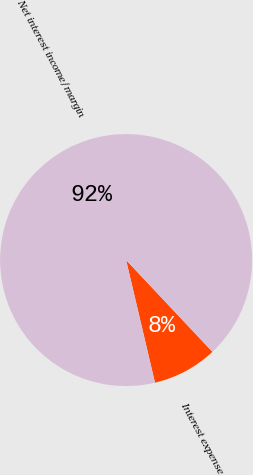Convert chart to OTSL. <chart><loc_0><loc_0><loc_500><loc_500><pie_chart><fcel>Interest expense<fcel>Net interest income/margin<nl><fcel>8.33%<fcel>91.67%<nl></chart> 